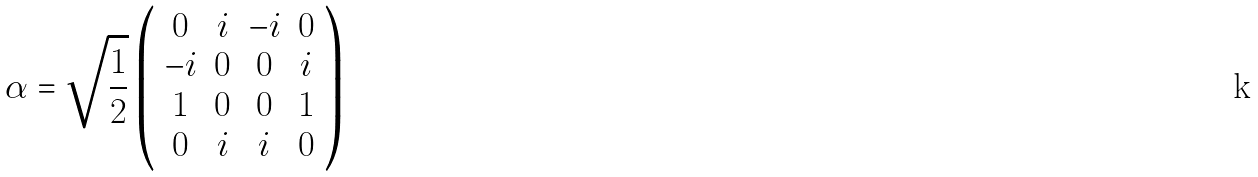<formula> <loc_0><loc_0><loc_500><loc_500>\alpha = \sqrt { \frac { 1 } { 2 } } \left ( \begin{array} { c c c c } 0 & i & - i & 0 \\ - i & 0 & 0 & i \\ 1 & 0 & 0 & 1 \\ 0 & i & i & 0 \end{array} \right )</formula> 